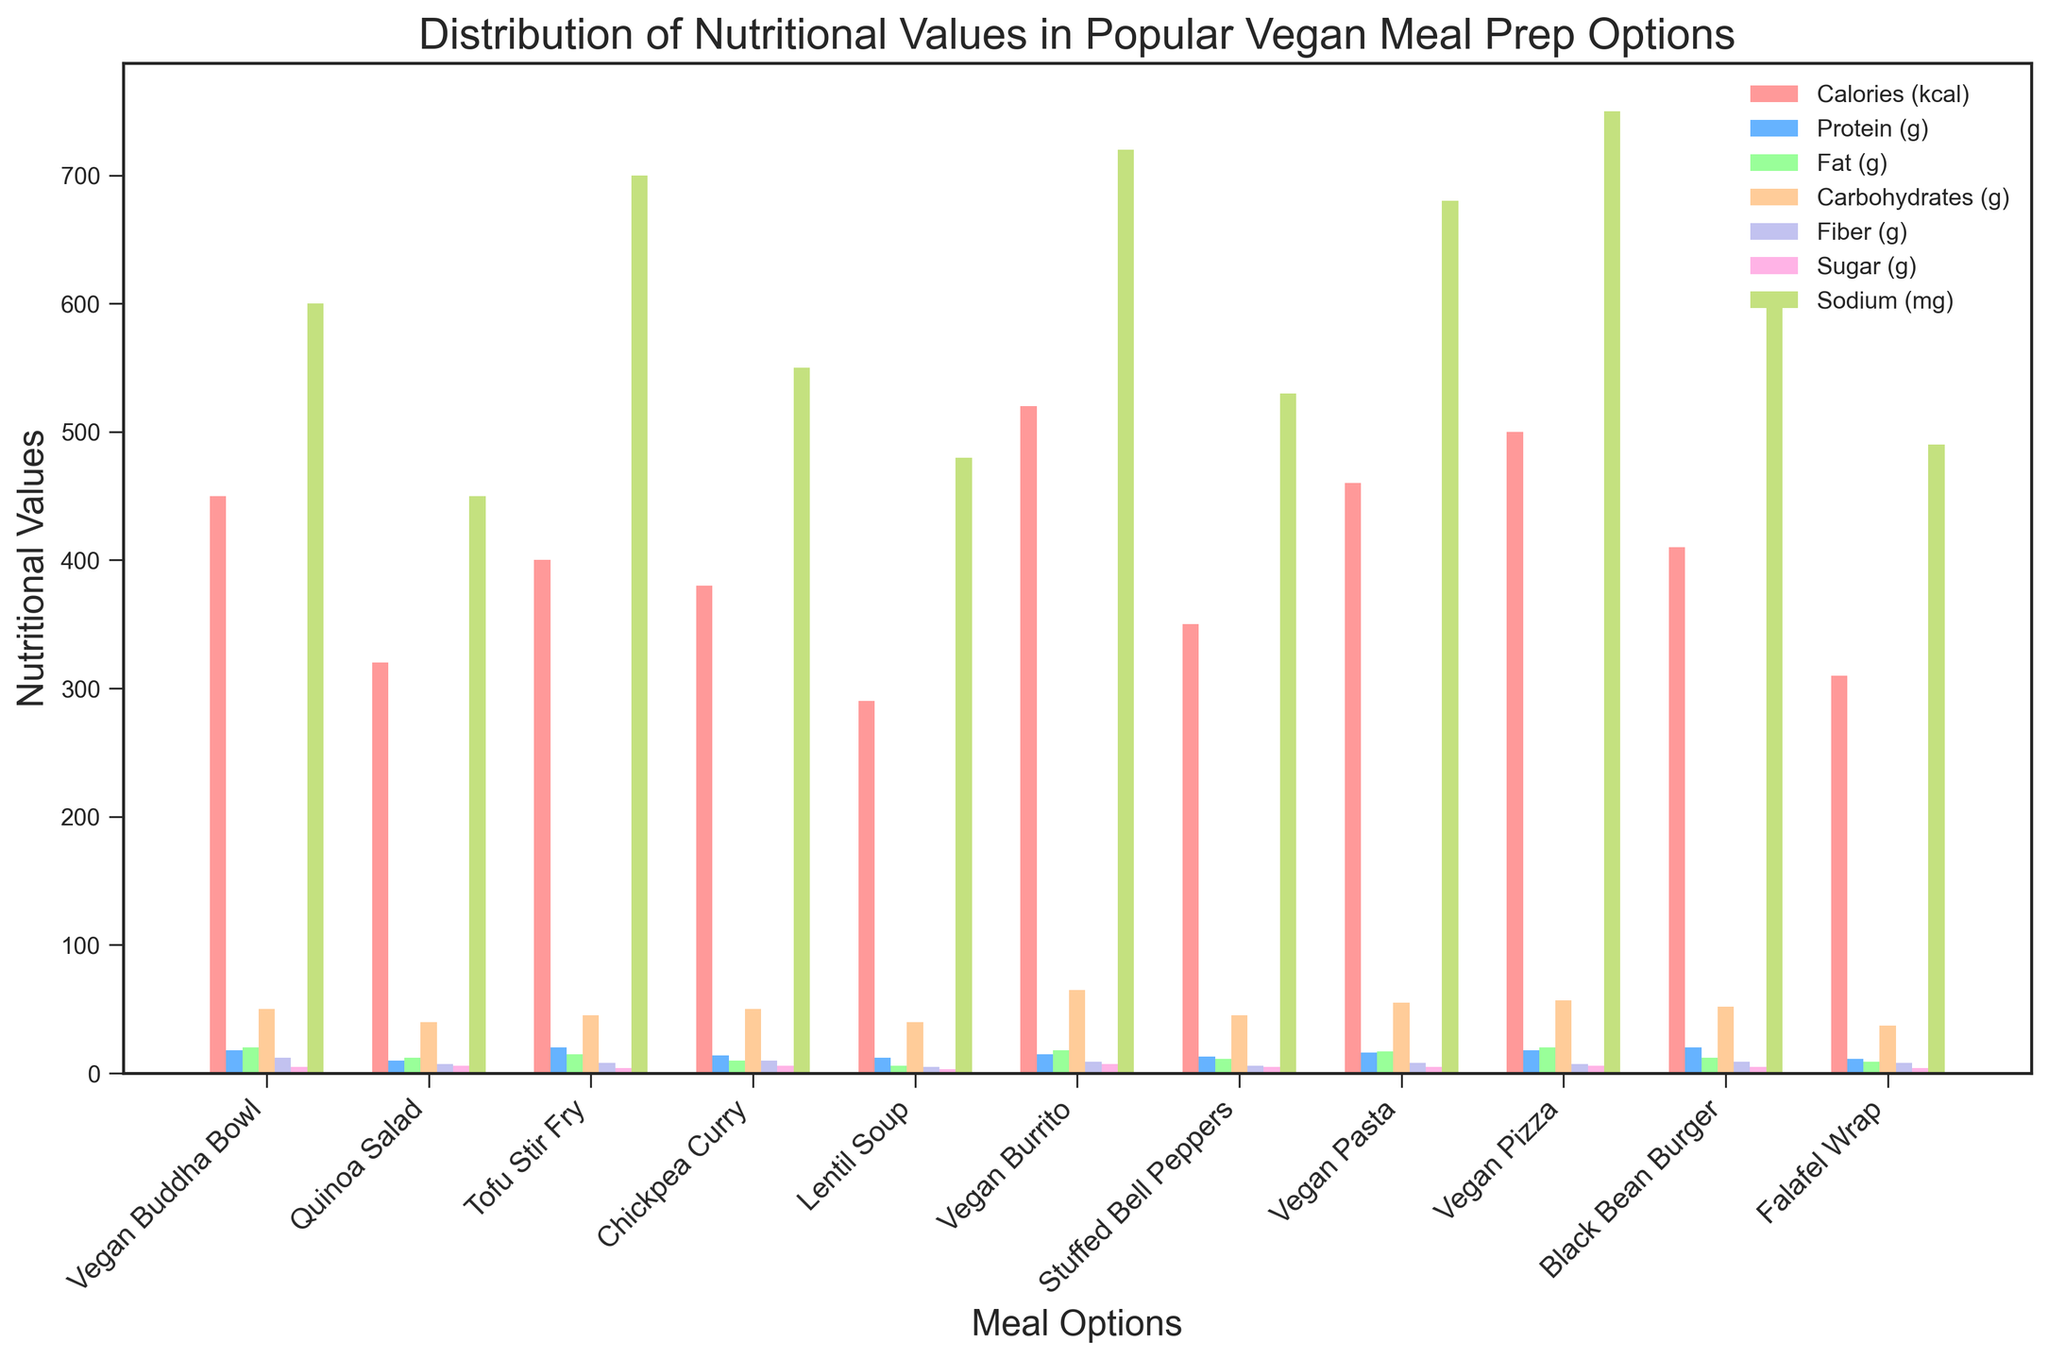What's the highest sodium content meal option? The tallest bar in the “Sodium (mg)” group will indicate the highest sodium content. By looking at the sodium bars, the measure for Vegan Pizza is the highest.
Answer: Vegan Pizza Which meal option has more protein: Vegan Buddha Bowl or Black Bean Burger? The height of the bars in the “Protein (g)” category should be compared for these two meals. The protein bar for Black Bean Burger is taller than for Vegan Buddha Bowl.
Answer: Black Bean Burger What is the combined sugar content of Quinoa Salad and Vegan Pizza? Add the sugar values for Quinoa Salad and Vegan Pizza by finding the height of the bars in the “Sugar (g)” category for these two meals. Quinoa Salad has 6g and Vegan Pizza has 6g, so combined it is 6 + 6.
Answer: 12g Among Chickpea Curry, Falafel Wrap, and Lentil Soup, which meal has the lowest calorie content? Compare the height of the calorie bars for these three meals. The Falafel Wrap has the shortest calorie bar.
Answer: Falafel Wrap Which meal has the most balanced macronutrient profile (similar heights for protein, fat, carbohydrates)? Look at the bars of protein, fat, and carbohydrates for each meal to find the one with similar heights across these categories. Tofu Stir Fry has relatively balanced heights across protein, fat, and carbohydrates.
Answer: Tofu Stir Fry Is the fiber content of the Vegan Burrito higher than the carbohydrates content of the Falafel Wrap? Compare the height of the fiber bar of Vegan Burrito with the height of the carbohydrate bar of the Falafel Wrap. The fiber bar (9g) of Vegan Burrito is shorter than the carbohydrate bar (37g) of Falafel Wrap.
Answer: No What is the average fat content for the Vegan Buddha Bowl, Vegan Pizza, and Vegan Burrito? Sum up the fat content values for these three meals and then divide by 3: Vegan Buddha Bowl (20g), Vegan Pizza (20g), and Vegan Burrito (18g). So (20 + 20 + 18)/3 = 58/3.
Answer: 19.33g Which meal option has the highest level of fiber? Identify the tallest bar in the “Fiber (g)” category. The Vegan Buddha Bowl has the highest fiber content (12g).
Answer: Vegan Buddha Bowl Does the Vegan Pasta have more carbohydrates than the Vegan Pizza? Compare the height of the carbohydrate bars for Vegan Pasta and Vegan Pizza. The carbohydrate bar for Vegan Pasta is shorter than that for Vegan Pizza.
Answer: No 